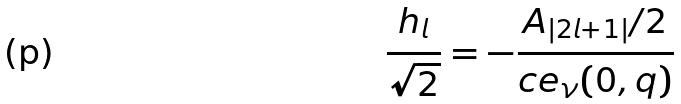Convert formula to latex. <formula><loc_0><loc_0><loc_500><loc_500>\frac { h _ { l } } { \sqrt { 2 } } = - \frac { A _ { | 2 l + 1 | } / 2 } { c e _ { \nu } ( 0 , q ) }</formula> 